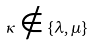<formula> <loc_0><loc_0><loc_500><loc_500>\kappa \notin \{ \lambda , \mu \}</formula> 